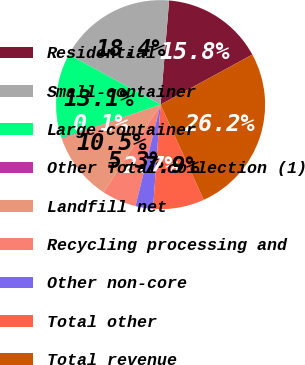Convert chart to OTSL. <chart><loc_0><loc_0><loc_500><loc_500><pie_chart><fcel>Residential<fcel>Small-container<fcel>Large-container<fcel>Other Total collection (1)<fcel>Landfill net<fcel>Recycling processing and<fcel>Other non-core<fcel>Total other<fcel>Total revenue<nl><fcel>15.75%<fcel>18.35%<fcel>13.14%<fcel>0.1%<fcel>10.53%<fcel>5.32%<fcel>2.71%<fcel>7.93%<fcel>26.17%<nl></chart> 